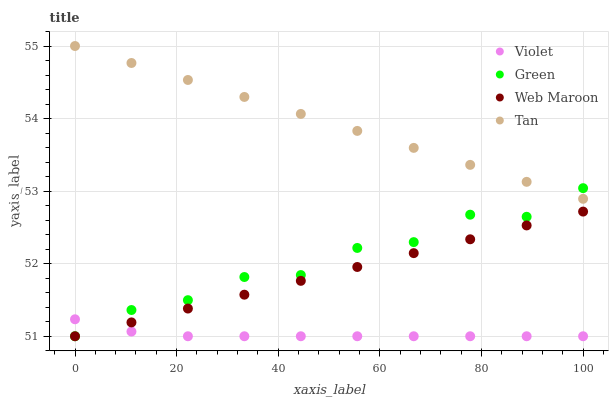Does Violet have the minimum area under the curve?
Answer yes or no. Yes. Does Tan have the maximum area under the curve?
Answer yes or no. Yes. Does Green have the minimum area under the curve?
Answer yes or no. No. Does Green have the maximum area under the curve?
Answer yes or no. No. Is Tan the smoothest?
Answer yes or no. Yes. Is Green the roughest?
Answer yes or no. Yes. Is Green the smoothest?
Answer yes or no. No. Is Tan the roughest?
Answer yes or no. No. Does Web Maroon have the lowest value?
Answer yes or no. Yes. Does Tan have the lowest value?
Answer yes or no. No. Does Tan have the highest value?
Answer yes or no. Yes. Does Green have the highest value?
Answer yes or no. No. Is Violet less than Tan?
Answer yes or no. Yes. Is Tan greater than Violet?
Answer yes or no. Yes. Does Green intersect Violet?
Answer yes or no. Yes. Is Green less than Violet?
Answer yes or no. No. Is Green greater than Violet?
Answer yes or no. No. Does Violet intersect Tan?
Answer yes or no. No. 